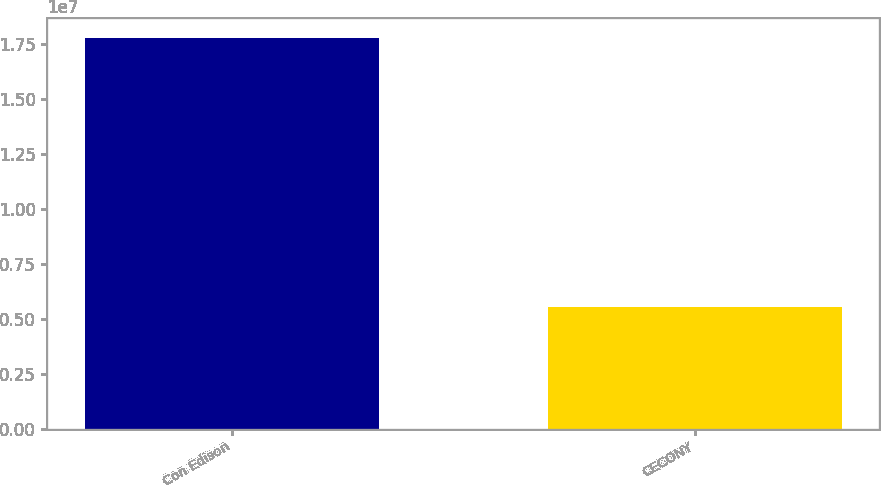<chart> <loc_0><loc_0><loc_500><loc_500><bar_chart><fcel>Con Edison<fcel>CECONY<nl><fcel>1.77926e+07<fcel>5.54325e+06<nl></chart> 